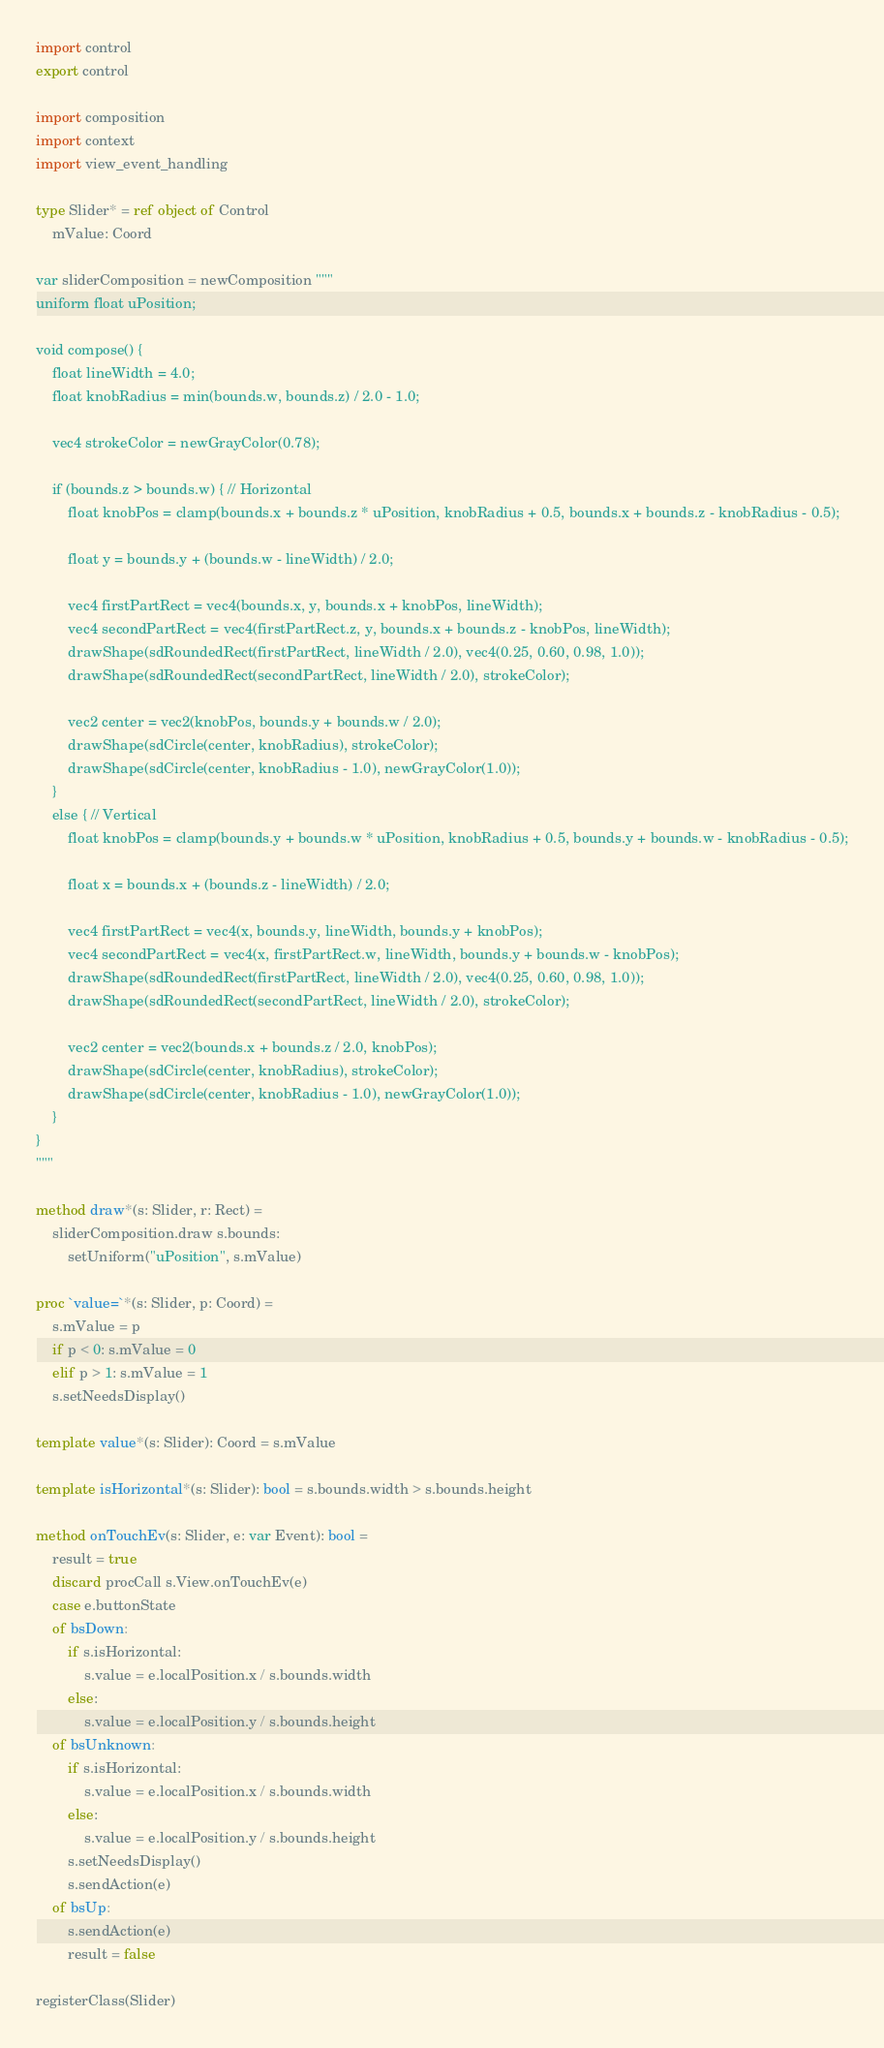Convert code to text. <code><loc_0><loc_0><loc_500><loc_500><_Nim_>import control
export control

import composition
import context
import view_event_handling

type Slider* = ref object of Control
    mValue: Coord

var sliderComposition = newComposition """
uniform float uPosition;

void compose() {
    float lineWidth = 4.0;
    float knobRadius = min(bounds.w, bounds.z) / 2.0 - 1.0;

    vec4 strokeColor = newGrayColor(0.78);

    if (bounds.z > bounds.w) { // Horizontal
        float knobPos = clamp(bounds.x + bounds.z * uPosition, knobRadius + 0.5, bounds.x + bounds.z - knobRadius - 0.5);

        float y = bounds.y + (bounds.w - lineWidth) / 2.0;

        vec4 firstPartRect = vec4(bounds.x, y, bounds.x + knobPos, lineWidth);
        vec4 secondPartRect = vec4(firstPartRect.z, y, bounds.x + bounds.z - knobPos, lineWidth);
        drawShape(sdRoundedRect(firstPartRect, lineWidth / 2.0), vec4(0.25, 0.60, 0.98, 1.0));
        drawShape(sdRoundedRect(secondPartRect, lineWidth / 2.0), strokeColor);

        vec2 center = vec2(knobPos, bounds.y + bounds.w / 2.0);
        drawShape(sdCircle(center, knobRadius), strokeColor);
        drawShape(sdCircle(center, knobRadius - 1.0), newGrayColor(1.0));
    }
    else { // Vertical
        float knobPos = clamp(bounds.y + bounds.w * uPosition, knobRadius + 0.5, bounds.y + bounds.w - knobRadius - 0.5);

        float x = bounds.x + (bounds.z - lineWidth) / 2.0;

        vec4 firstPartRect = vec4(x, bounds.y, lineWidth, bounds.y + knobPos);
        vec4 secondPartRect = vec4(x, firstPartRect.w, lineWidth, bounds.y + bounds.w - knobPos);
        drawShape(sdRoundedRect(firstPartRect, lineWidth / 2.0), vec4(0.25, 0.60, 0.98, 1.0));
        drawShape(sdRoundedRect(secondPartRect, lineWidth / 2.0), strokeColor);

        vec2 center = vec2(bounds.x + bounds.z / 2.0, knobPos);
        drawShape(sdCircle(center, knobRadius), strokeColor);
        drawShape(sdCircle(center, knobRadius - 1.0), newGrayColor(1.0));
    }
}
"""

method draw*(s: Slider, r: Rect) =
    sliderComposition.draw s.bounds:
        setUniform("uPosition", s.mValue)

proc `value=`*(s: Slider, p: Coord) =
    s.mValue = p
    if p < 0: s.mValue = 0
    elif p > 1: s.mValue = 1
    s.setNeedsDisplay()

template value*(s: Slider): Coord = s.mValue

template isHorizontal*(s: Slider): bool = s.bounds.width > s.bounds.height

method onTouchEv(s: Slider, e: var Event): bool =
    result = true
    discard procCall s.View.onTouchEv(e)
    case e.buttonState
    of bsDown:
        if s.isHorizontal:
            s.value = e.localPosition.x / s.bounds.width
        else:
            s.value = e.localPosition.y / s.bounds.height
    of bsUnknown:
        if s.isHorizontal:
            s.value = e.localPosition.x / s.bounds.width
        else:
            s.value = e.localPosition.y / s.bounds.height
        s.setNeedsDisplay()
        s.sendAction(e)
    of bsUp:
        s.sendAction(e)
        result = false

registerClass(Slider)
</code> 